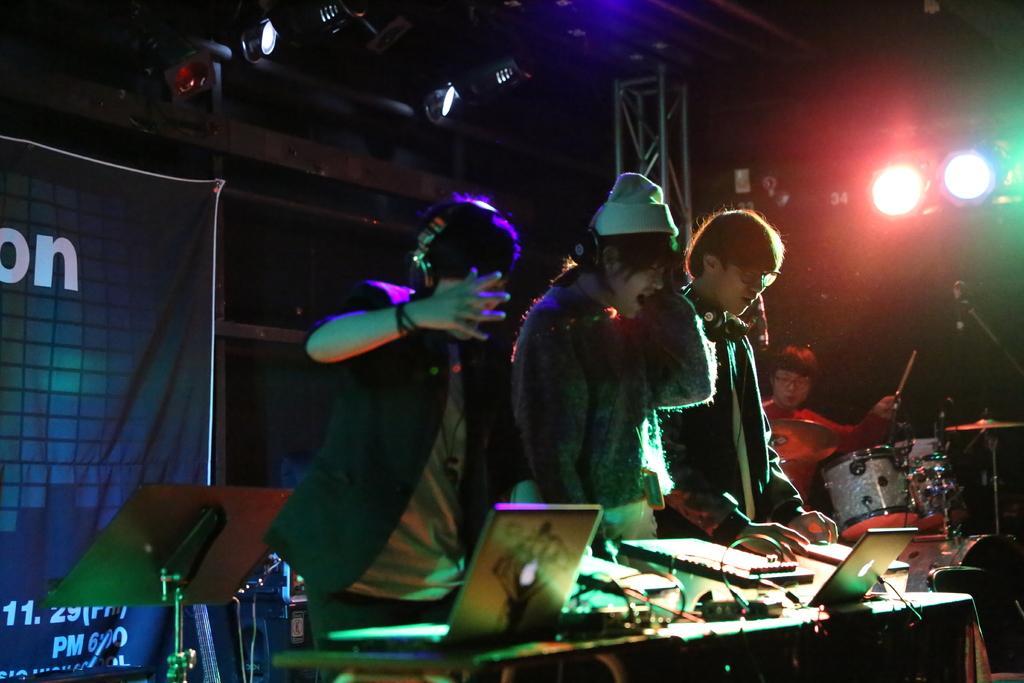Could you give a brief overview of what you see in this image? This image is taken in a concert. On the left side of the image there is a banner with a text on it. At the top of the image there are a few lights. On the right side of the image a man is playing drums. In the middle of the image there is a table with a few things on it and three men are standing on the floor. 